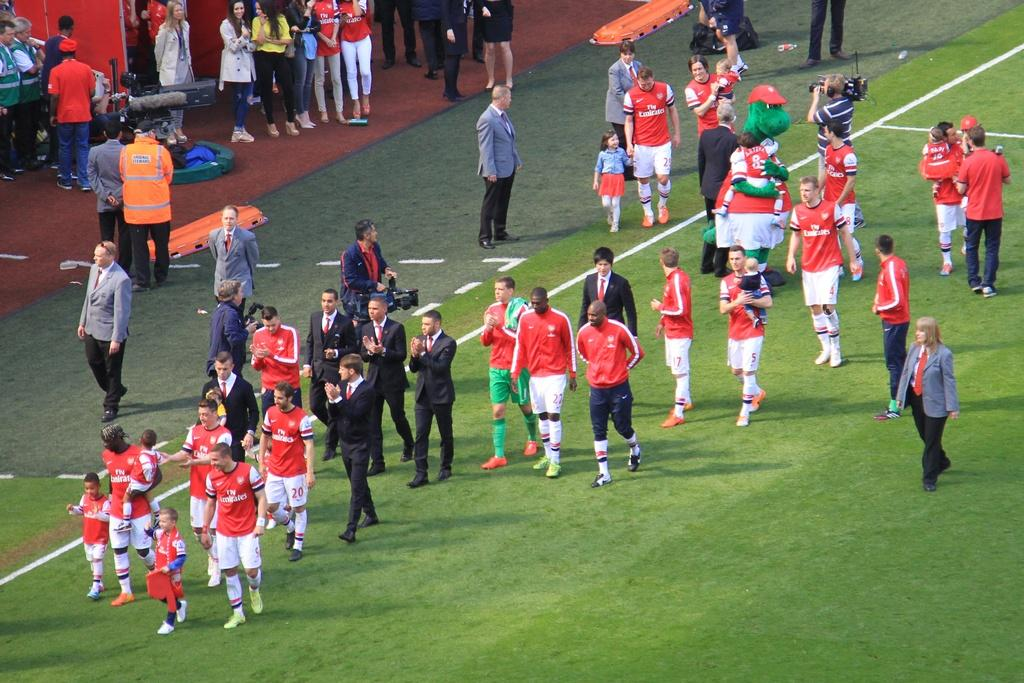<image>
Provide a brief description of the given image. a group of players with fly emirates written on their shirts 